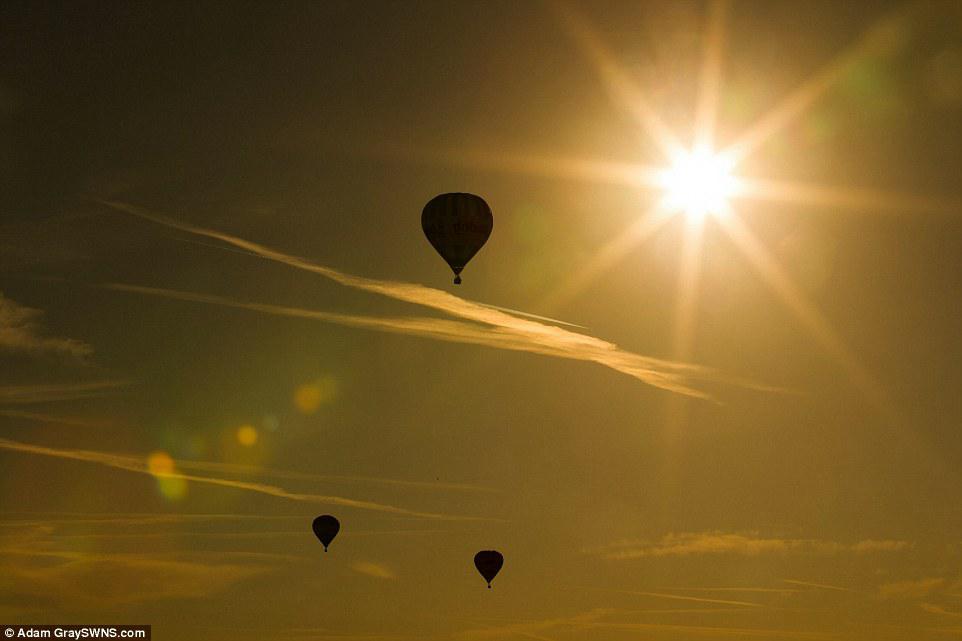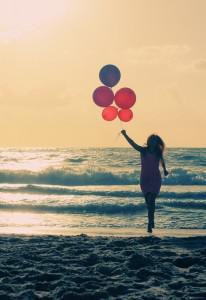The first image is the image on the left, the second image is the image on the right. Examine the images to the left and right. Is the description "At least one image has exactly three balloons." accurate? Answer yes or no. Yes. 